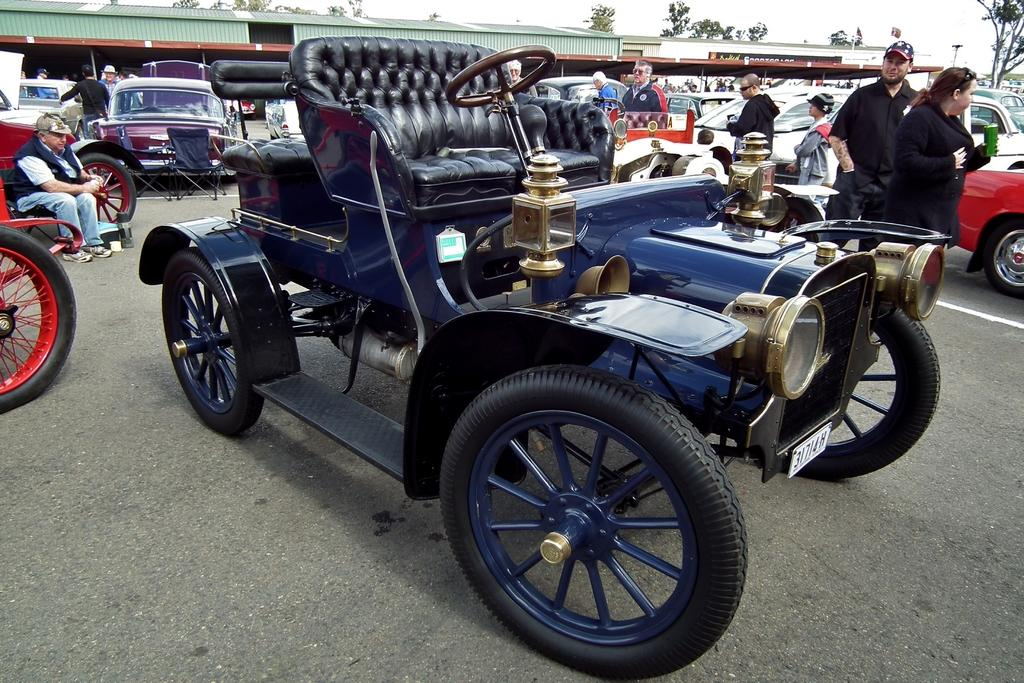What is the main feature of the image? There is a road in the image. What else can be seen on the road? There are vehicles in the image. Are there any people present in the image? Yes, there are persons in the image. Can you describe the position of one of the persons in the image? There is a person sitting towards the left of the image. What other structures or objects can be seen in the image? There is a shed and trees in the image. What can be seen in the background of the image? The sky is visible in the image. What type of oatmeal is being served at the shed in the image? There is no oatmeal present in the image, nor is there any indication of food being served. 